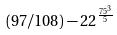Convert formula to latex. <formula><loc_0><loc_0><loc_500><loc_500>( 9 7 / 1 0 8 ) - 2 2 ^ { \frac { 7 5 ^ { 3 } } { 5 } }</formula> 